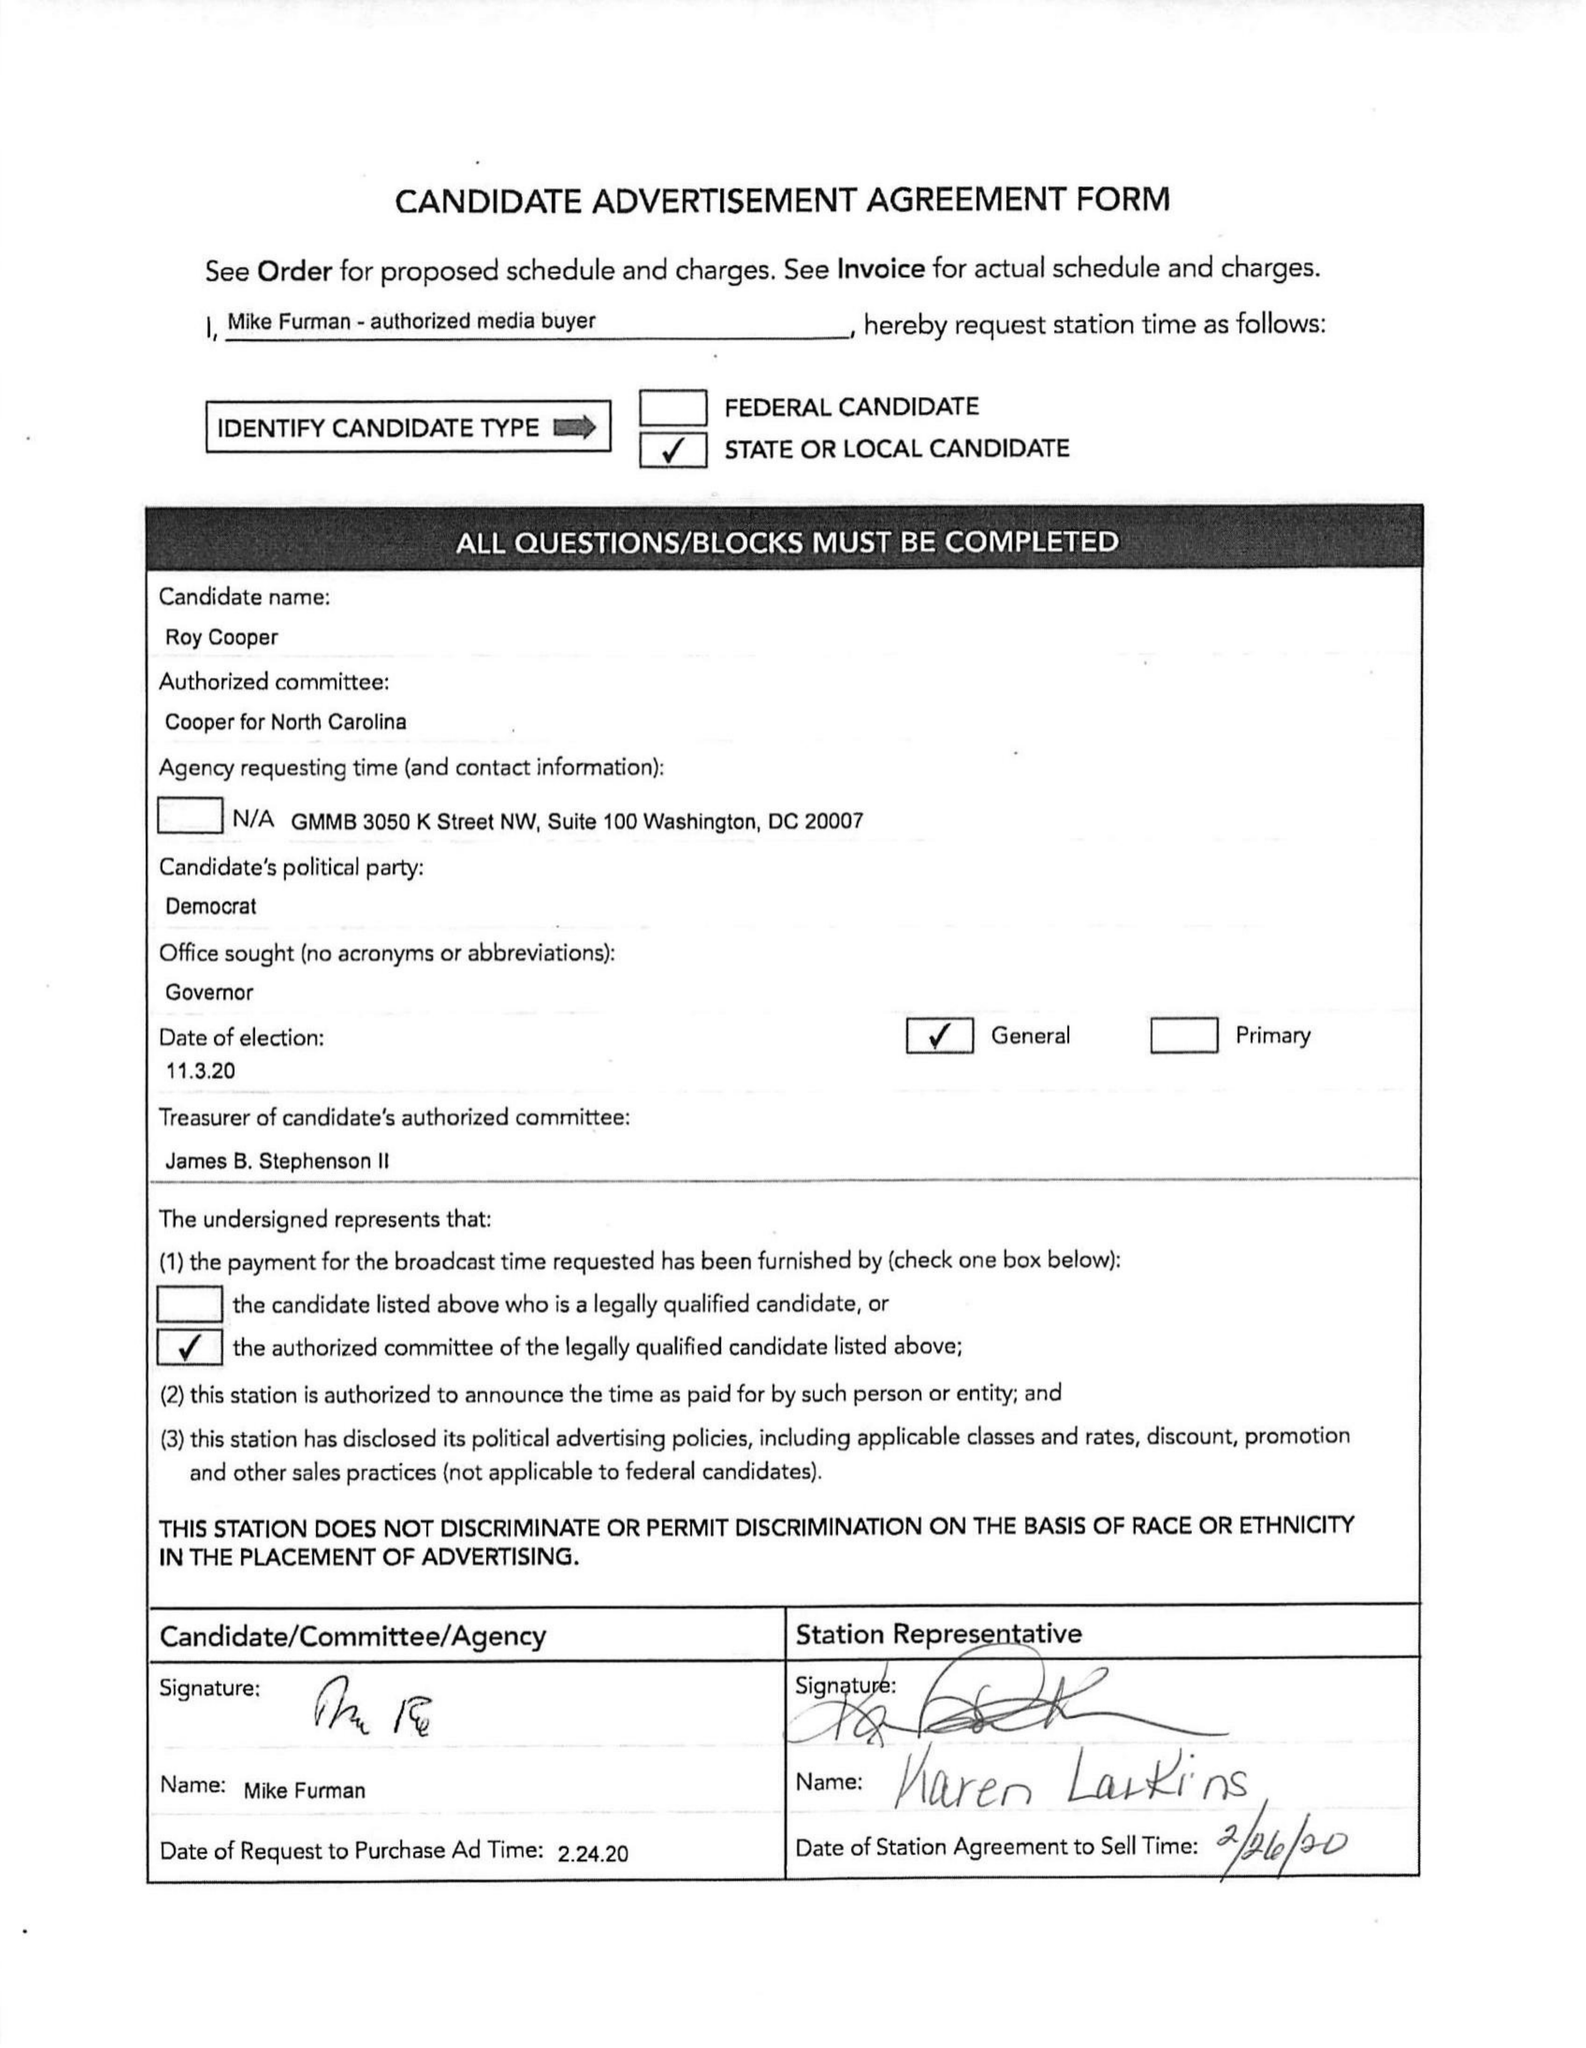What is the value for the contract_num?
Answer the question using a single word or phrase. 1537713 